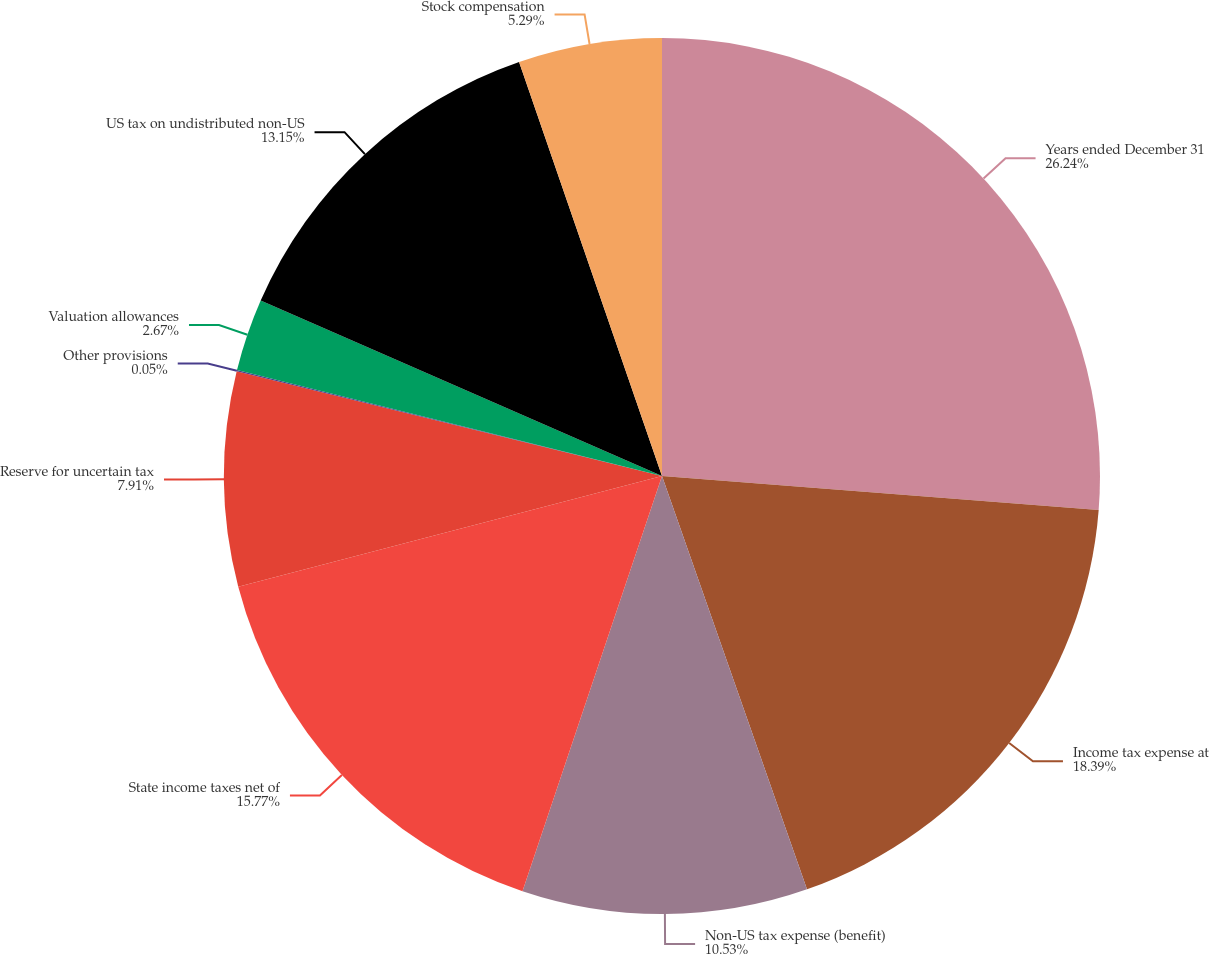<chart> <loc_0><loc_0><loc_500><loc_500><pie_chart><fcel>Years ended December 31<fcel>Income tax expense at<fcel>Non-US tax expense (benefit)<fcel>State income taxes net of<fcel>Reserve for uncertain tax<fcel>Other provisions<fcel>Valuation allowances<fcel>US tax on undistributed non-US<fcel>Stock compensation<nl><fcel>26.24%<fcel>18.39%<fcel>10.53%<fcel>15.77%<fcel>7.91%<fcel>0.05%<fcel>2.67%<fcel>13.15%<fcel>5.29%<nl></chart> 